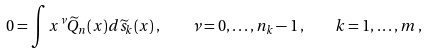Convert formula to latex. <formula><loc_0><loc_0><loc_500><loc_500>0 = \int x ^ { \nu } \widetilde { Q } _ { n } ( x ) d \widetilde { s } _ { k } ( x ) \, , \quad \nu = 0 , \dots , n _ { k } - 1 \, , \quad k = 1 , \dots , m \, ,</formula> 